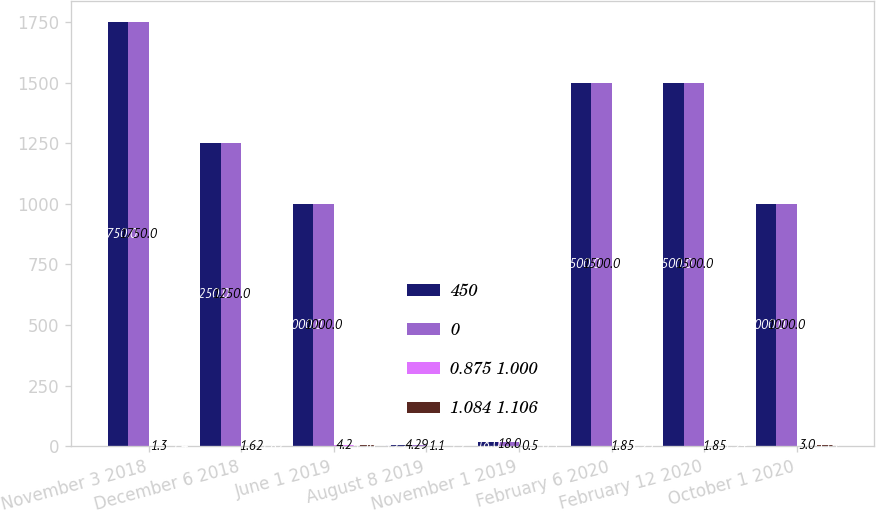<chart> <loc_0><loc_0><loc_500><loc_500><stacked_bar_chart><ecel><fcel>November 3 2018<fcel>December 6 2018<fcel>June 1 2019<fcel>August 8 2019<fcel>November 1 2019<fcel>February 6 2020<fcel>February 12 2020<fcel>October 1 2020<nl><fcel>450<fcel>1750<fcel>1250<fcel>1000<fcel>4.29<fcel>18<fcel>1500<fcel>1500<fcel>1000<nl><fcel>0<fcel>1750<fcel>1250<fcel>1000<fcel>4.29<fcel>18<fcel>1500<fcel>1500<fcel>1000<nl><fcel>0.875 1.000<fcel>1.3<fcel>1.62<fcel>4.2<fcel>1.1<fcel>0.5<fcel>1.85<fcel>1.85<fcel>3<nl><fcel>1.084 1.106<fcel>1.4<fcel>1.82<fcel>4.38<fcel>1.2<fcel>0.5<fcel>1.95<fcel>1.94<fcel>3.14<nl></chart> 